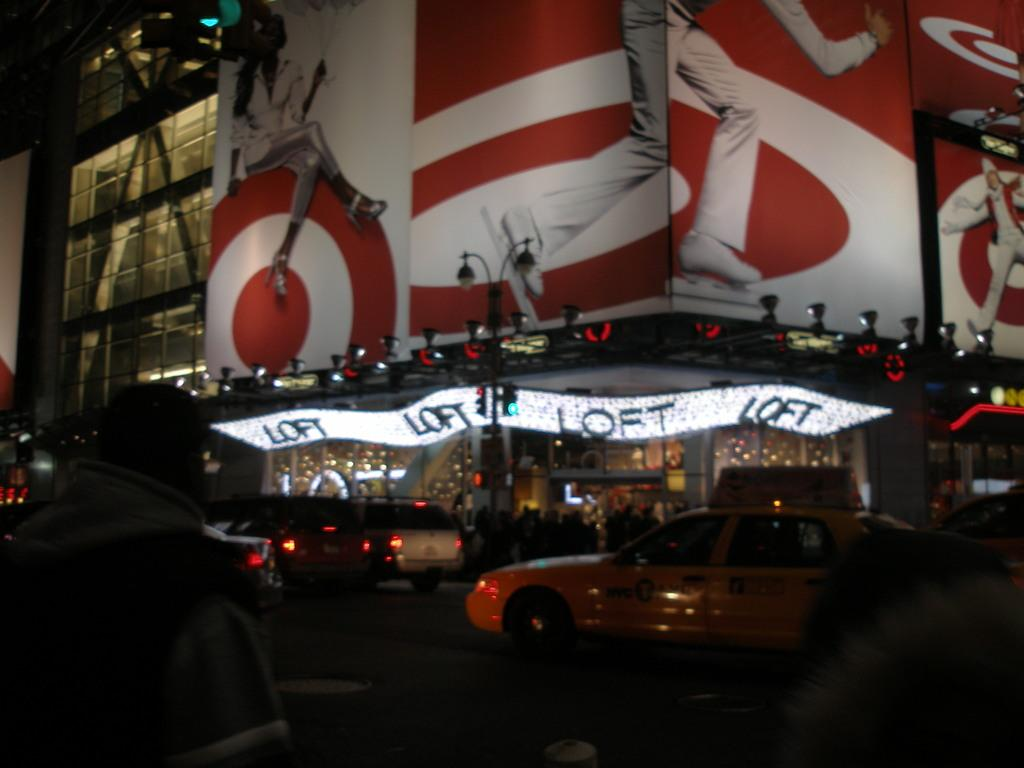<image>
Write a terse but informative summary of the picture. On a building outside at night, a bright sign advertises "Loft." 